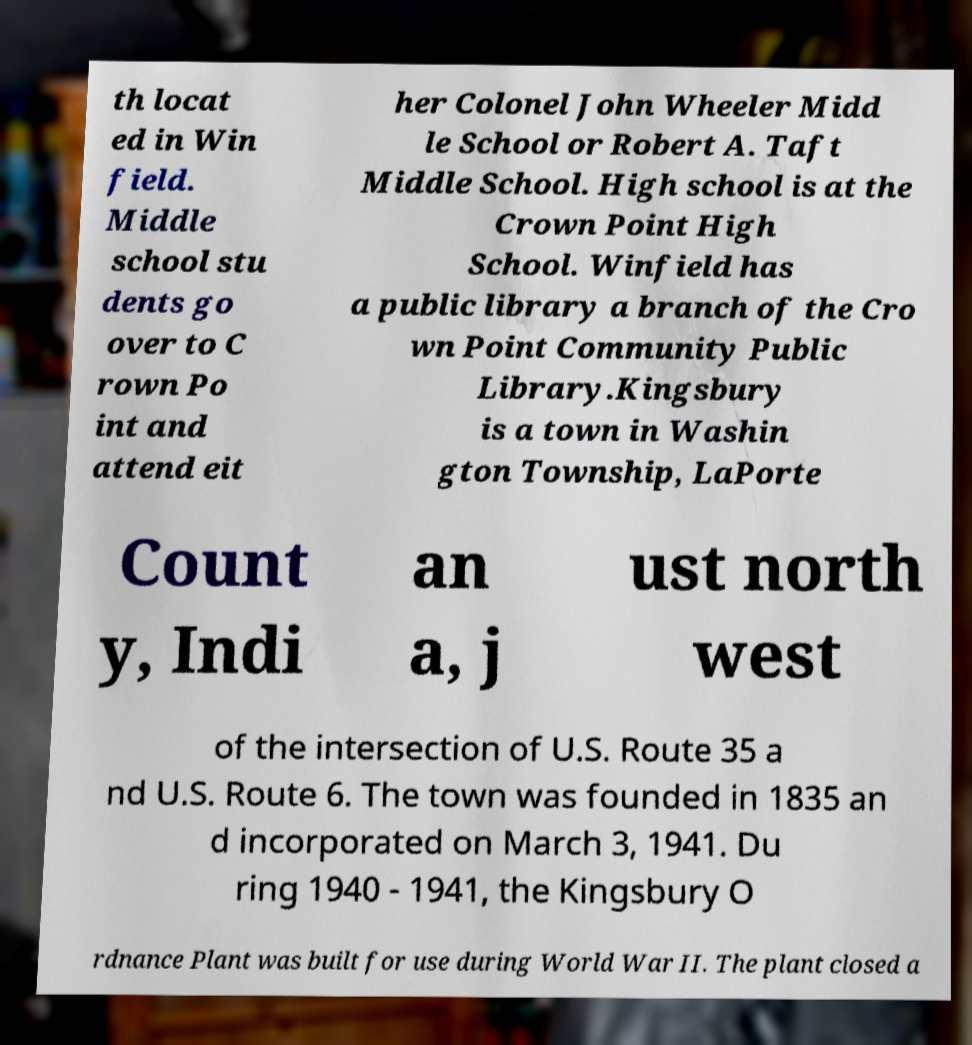Can you read and provide the text displayed in the image?This photo seems to have some interesting text. Can you extract and type it out for me? th locat ed in Win field. Middle school stu dents go over to C rown Po int and attend eit her Colonel John Wheeler Midd le School or Robert A. Taft Middle School. High school is at the Crown Point High School. Winfield has a public library a branch of the Cro wn Point Community Public Library.Kingsbury is a town in Washin gton Township, LaPorte Count y, Indi an a, j ust north west of the intersection of U.S. Route 35 a nd U.S. Route 6. The town was founded in 1835 an d incorporated on March 3, 1941. Du ring 1940 - 1941, the Kingsbury O rdnance Plant was built for use during World War II. The plant closed a 